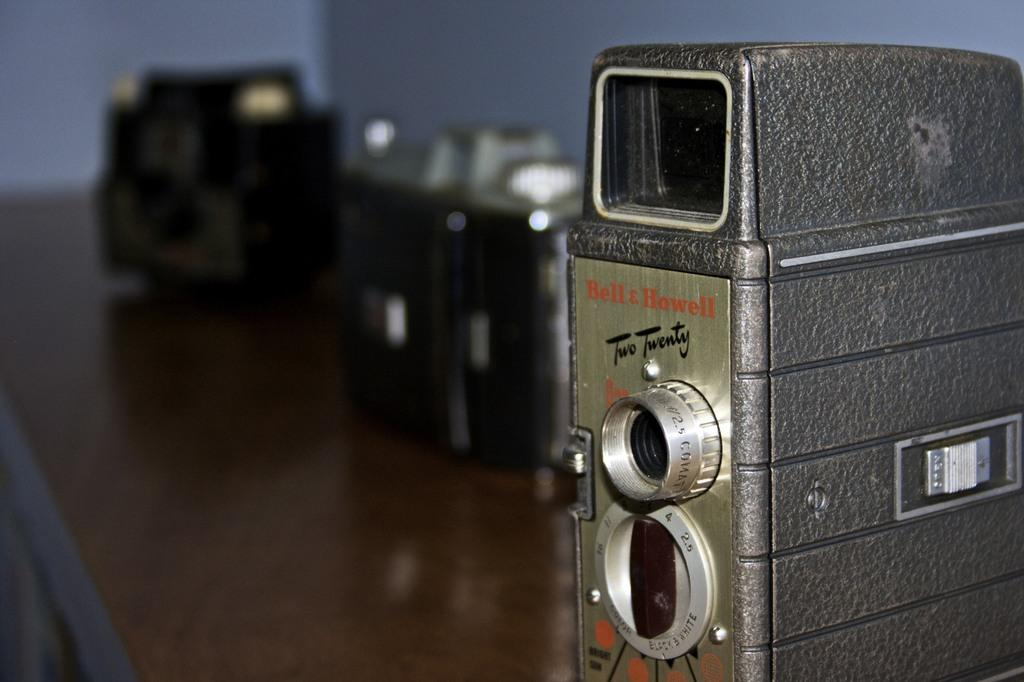What objects can be seen on the surface in the image? There are devices placed on a surface in the image. What is visible at the top of the image? There is a wall visible at the top of the image. How many people have been affected by the mass in the image? There is no mass present in the image, so it is not possible to determine how many people have been affected. 